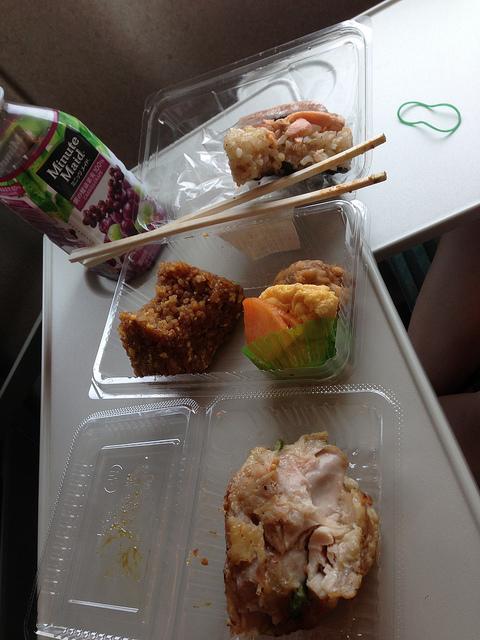What is to drink with lunch?
Short answer required. Juice. Where is the chopstick?
Give a very brief answer. Container. What utensils was the diner using?
Write a very short answer. Chopsticks. 